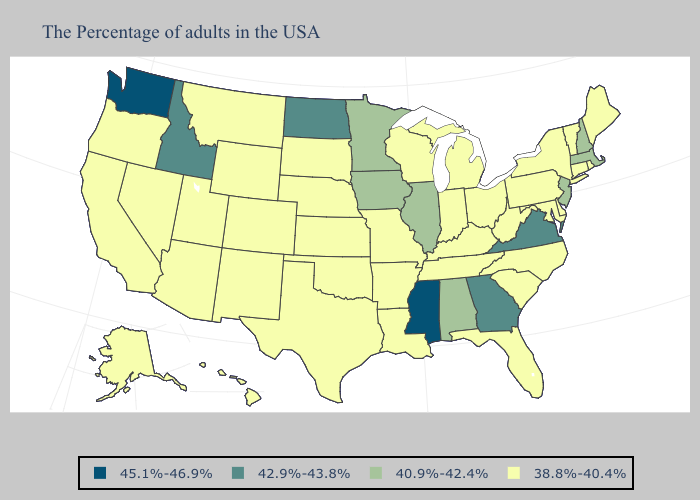What is the value of Maryland?
Be succinct. 38.8%-40.4%. Among the states that border Kansas , which have the lowest value?
Write a very short answer. Missouri, Nebraska, Oklahoma, Colorado. Among the states that border Nebraska , does Iowa have the lowest value?
Answer briefly. No. What is the lowest value in the MidWest?
Keep it brief. 38.8%-40.4%. What is the value of Connecticut?
Short answer required. 38.8%-40.4%. What is the value of West Virginia?
Answer briefly. 38.8%-40.4%. What is the value of South Carolina?
Be succinct. 38.8%-40.4%. Which states hav the highest value in the South?
Answer briefly. Mississippi. What is the value of Missouri?
Quick response, please. 38.8%-40.4%. Name the states that have a value in the range 38.8%-40.4%?
Quick response, please. Maine, Rhode Island, Vermont, Connecticut, New York, Delaware, Maryland, Pennsylvania, North Carolina, South Carolina, West Virginia, Ohio, Florida, Michigan, Kentucky, Indiana, Tennessee, Wisconsin, Louisiana, Missouri, Arkansas, Kansas, Nebraska, Oklahoma, Texas, South Dakota, Wyoming, Colorado, New Mexico, Utah, Montana, Arizona, Nevada, California, Oregon, Alaska, Hawaii. What is the value of Indiana?
Keep it brief. 38.8%-40.4%. What is the lowest value in states that border Massachusetts?
Write a very short answer. 38.8%-40.4%. What is the value of Maine?
Give a very brief answer. 38.8%-40.4%. How many symbols are there in the legend?
Give a very brief answer. 4. Name the states that have a value in the range 38.8%-40.4%?
Answer briefly. Maine, Rhode Island, Vermont, Connecticut, New York, Delaware, Maryland, Pennsylvania, North Carolina, South Carolina, West Virginia, Ohio, Florida, Michigan, Kentucky, Indiana, Tennessee, Wisconsin, Louisiana, Missouri, Arkansas, Kansas, Nebraska, Oklahoma, Texas, South Dakota, Wyoming, Colorado, New Mexico, Utah, Montana, Arizona, Nevada, California, Oregon, Alaska, Hawaii. 